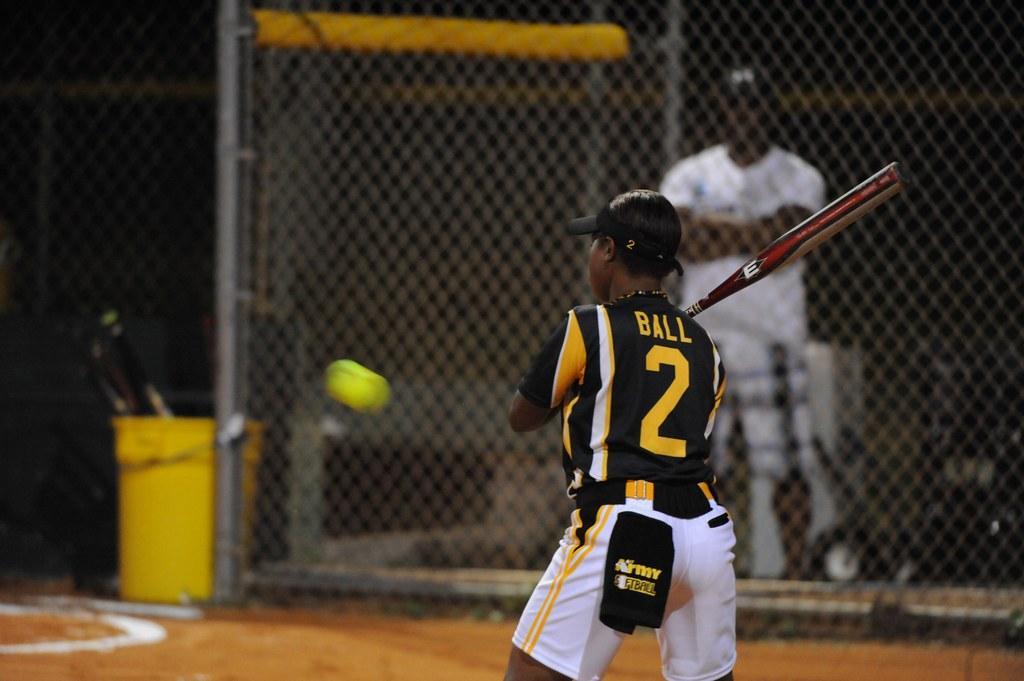<image>
Describe the image concisely. A baseball player with a number two on the back of their jersey is batting. 